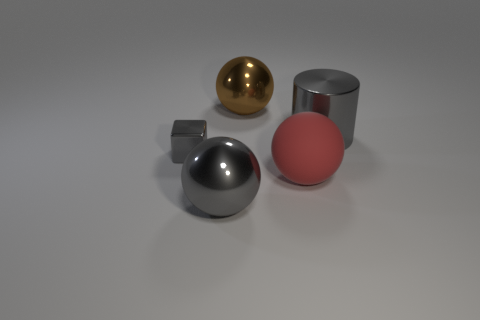Subtract all brown spheres. How many spheres are left? 2 Subtract all brown balls. How many balls are left? 2 Subtract 1 cylinders. How many cylinders are left? 0 Subtract all purple balls. Subtract all blue cubes. How many balls are left? 3 Subtract all yellow blocks. How many brown spheres are left? 1 Subtract all gray metallic blocks. Subtract all big gray metal spheres. How many objects are left? 3 Add 5 large gray cylinders. How many large gray cylinders are left? 6 Add 5 big gray metallic spheres. How many big gray metallic spheres exist? 6 Add 1 red rubber objects. How many objects exist? 6 Subtract 1 gray balls. How many objects are left? 4 